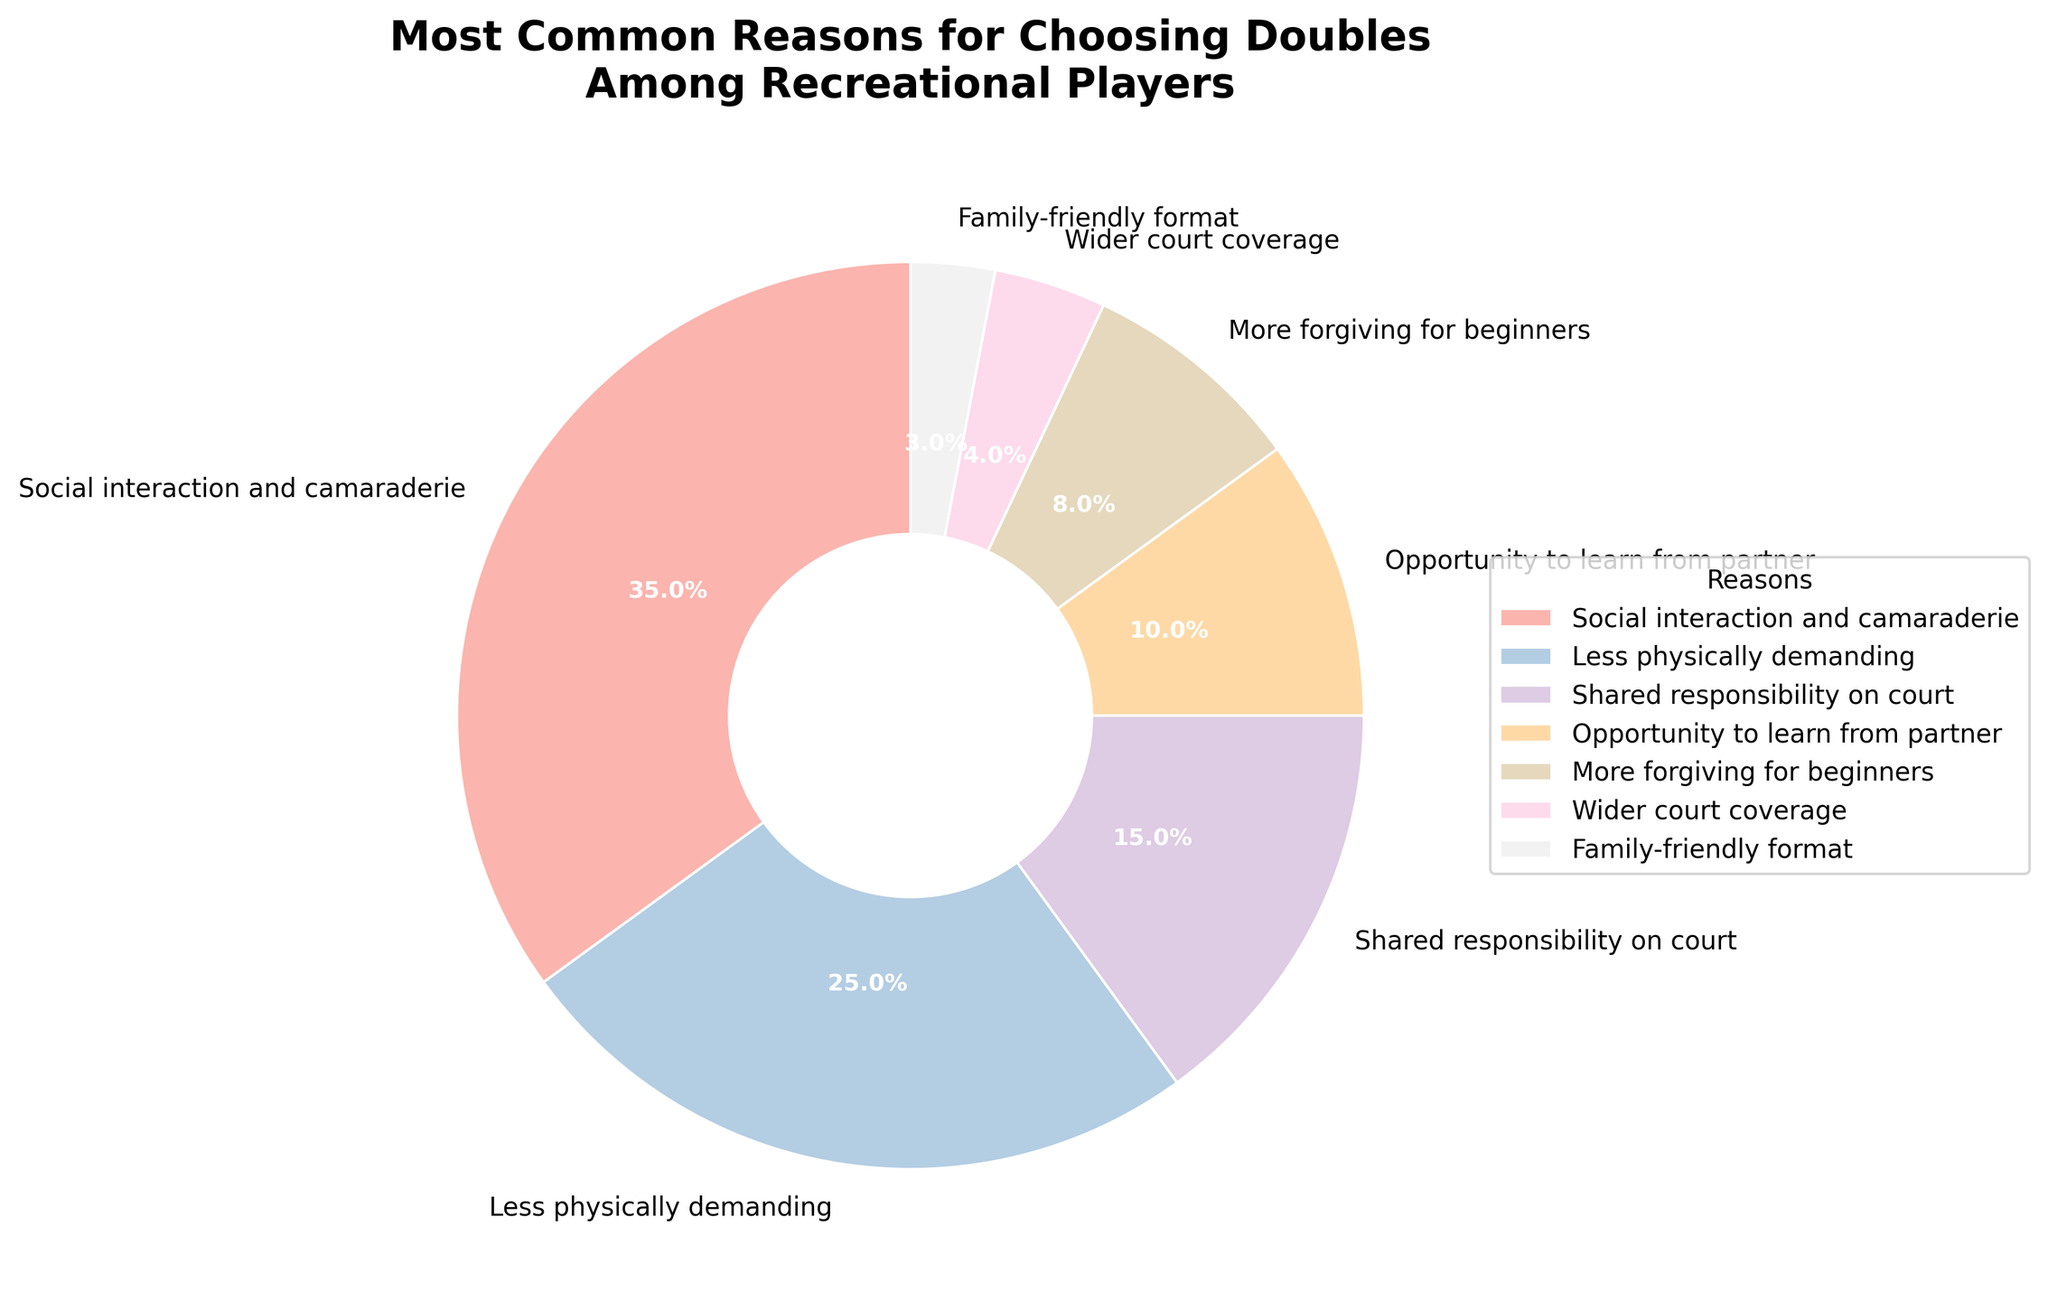What's the most common reason for choosing doubles over singles among recreational players? The pie chart shows the most common reason with the largest segment, labeled "Social interaction and camaraderie" at 35%.
Answer: Social interaction and camaraderie Which reason has the lowest percentage? The pie chart indicates the smallest segment is "Family-friendly format," which is labeled with 3%.
Answer: Family-friendly format What is the combined percentage of the top two reasons? The top two reasons are "Social interaction and camaraderie" (35%) and "Less physically demanding" (25%). Summing these percentages gives 35% + 25% = 60%.
Answer: 60% Which reason is more common: "More forgiving for beginners" or "Opportunity to learn from partner"? The pie chart shows "More forgiving for beginners" at 8% and "Opportunity to learn from partner" at 10%. Comparing these, "Opportunity to learn from partner" has a higher percentage.
Answer: Opportunity to learn from partner What is the total percentage of reasons related to learning and improvement? Two reasons related to learning and improvement are "Opportunity to learn from partner" (10%) and "More forgiving for beginners" (8%). Summing these percentages gives 10% + 8% = 18%.
Answer: 18% Which reasons together make up half of the total reasons? The reasons that combine to make 50% of the total are "Social interaction and camaraderie" (35%) and "Less physically demanding" (25%). Their combined percentage is 35% + 25% = 60%, which is above half. The next combination that just reaches 50% is "Social interaction and camaraderie" (35%) and "Less physically demanding" (25%) alone makes it 60%. Thus, the top reason alone accounts for more than half when taken together with any other reason, so just consider the first combination as the answer.
Answer: Social interaction and camaraderie and Less physically demanding What percentage of reasons are attributed to factors other than social interaction and physically demanding aspects? The total percentage excluding "Social interaction and camaraderie" (35%) and "Less physically demanding" (25%) is calculated as 100% - 35% - 25% = 40%.
Answer: 40% How many reasons have a percentage less than 10%? The pie chart shows reasons with less than 10% as "More forgiving for beginners" (8%), "Wider court coverage" (4%), and "Family-friendly format" (3%). There are three such reasons.
Answer: 3 What is the difference in percentage between "Shared responsibility on court" and "Opportunity to learn from partner"? The pie chart shows "Shared responsibility on court" at 15% and "Opportunity to learn from partner" at 10%. The difference is 15% - 10% = 5%.
Answer: 5% What is the least common reason among those with a percentage greater than 5%? Among the reasons with more than 5%: "Social interaction and camaraderie" (35%), "Less physically demanding" (25%), "Shared responsibility on court" (15%), "Opportunity to learn from partner" (10%), and "More forgiving for beginners" (8%), the least common is "More forgiving for beginners" at 8%.
Answer: More forgiving for beginners 